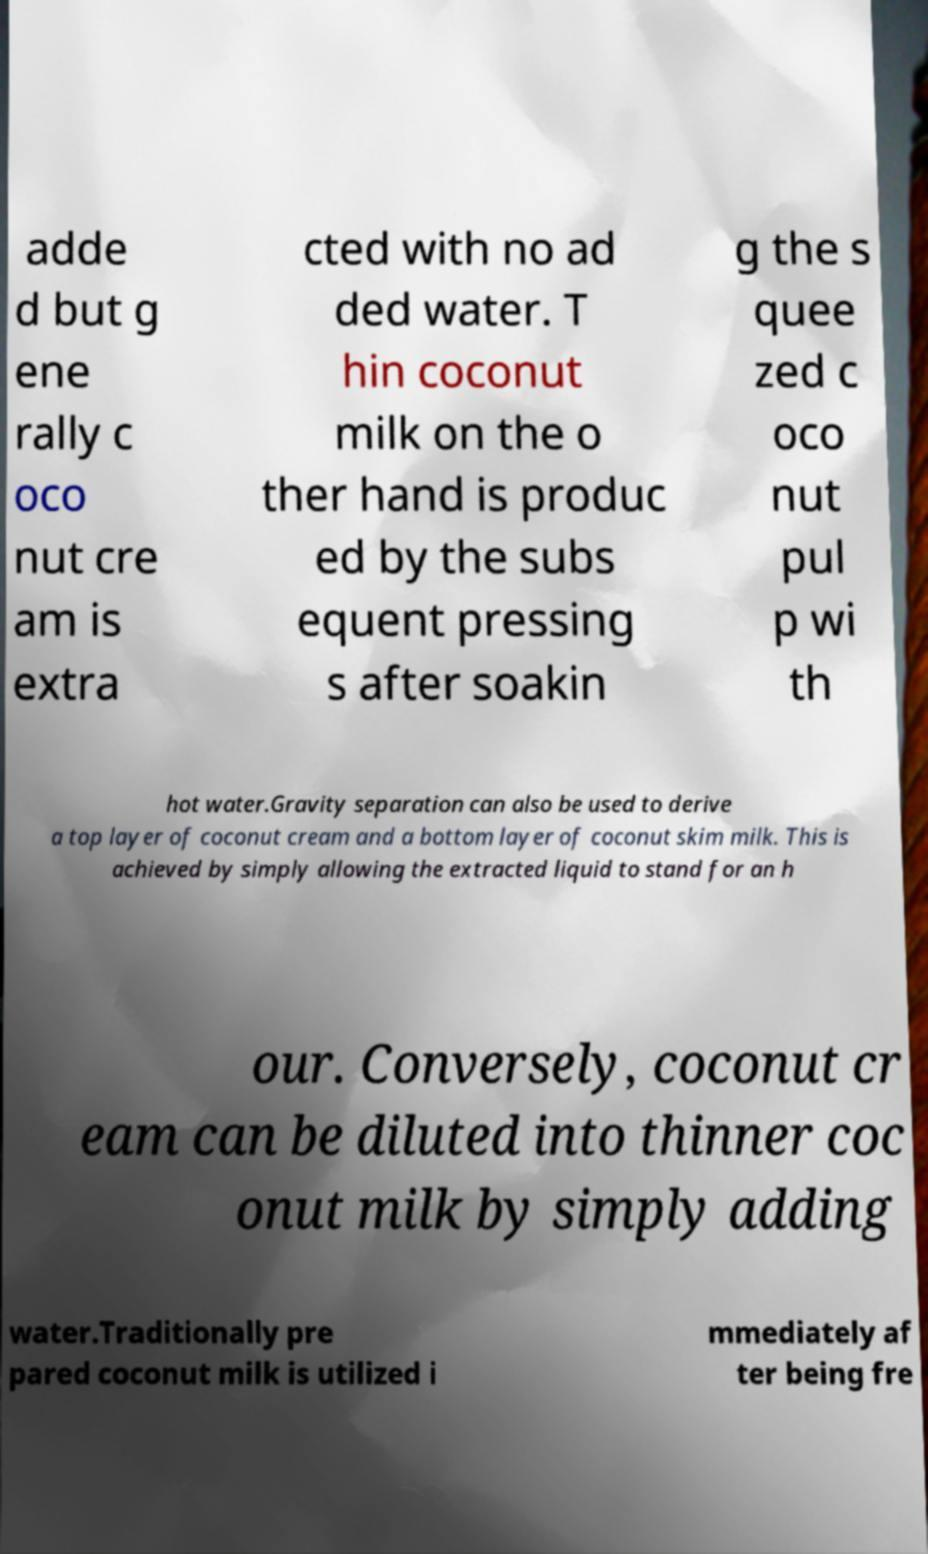Please read and relay the text visible in this image. What does it say? adde d but g ene rally c oco nut cre am is extra cted with no ad ded water. T hin coconut milk on the o ther hand is produc ed by the subs equent pressing s after soakin g the s quee zed c oco nut pul p wi th hot water.Gravity separation can also be used to derive a top layer of coconut cream and a bottom layer of coconut skim milk. This is achieved by simply allowing the extracted liquid to stand for an h our. Conversely, coconut cr eam can be diluted into thinner coc onut milk by simply adding water.Traditionally pre pared coconut milk is utilized i mmediately af ter being fre 